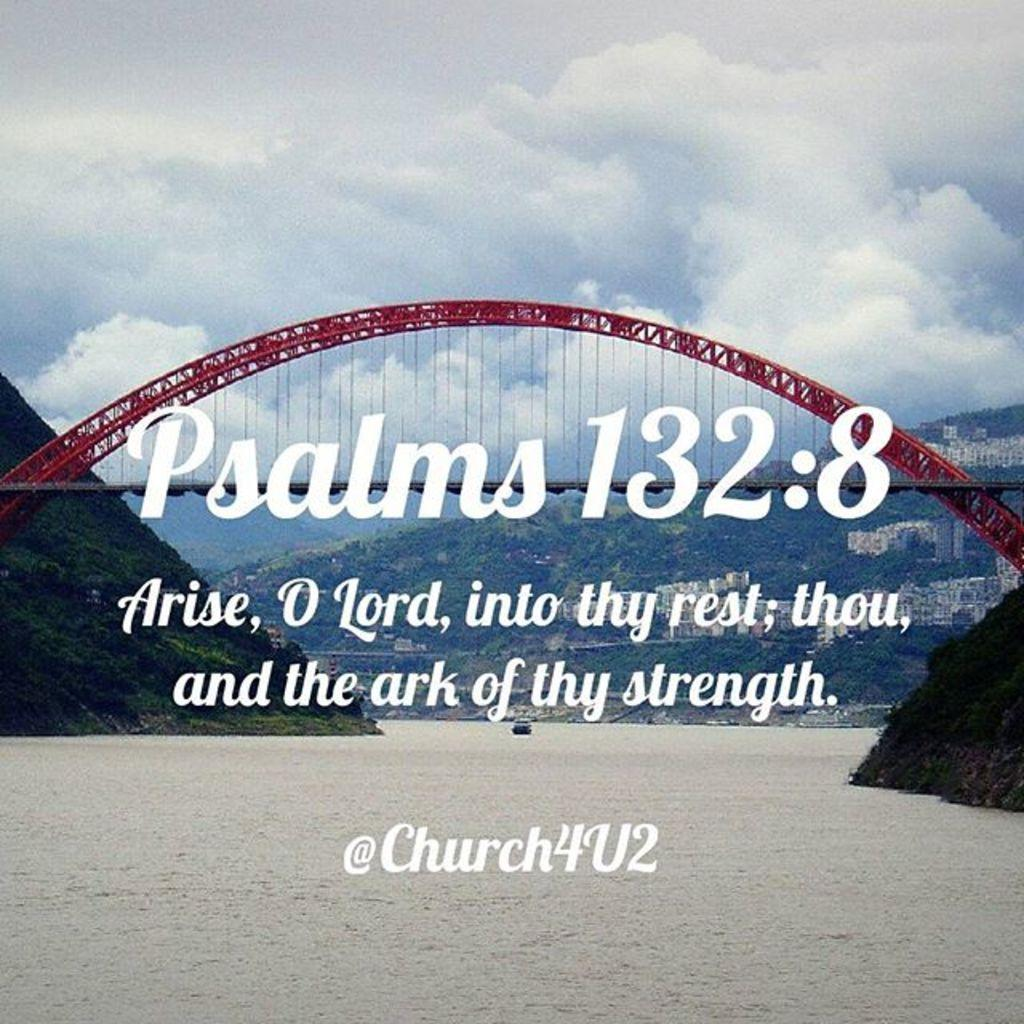<image>
Provide a brief description of the given image. A poster with a bridge image and Psalms 132:8 on it. 